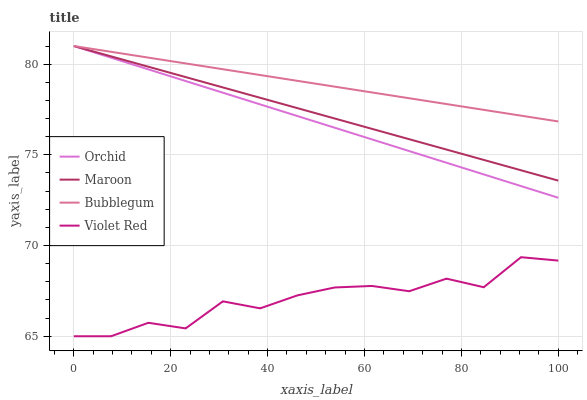Does Violet Red have the minimum area under the curve?
Answer yes or no. Yes. Does Bubblegum have the maximum area under the curve?
Answer yes or no. Yes. Does Maroon have the minimum area under the curve?
Answer yes or no. No. Does Maroon have the maximum area under the curve?
Answer yes or no. No. Is Bubblegum the smoothest?
Answer yes or no. Yes. Is Violet Red the roughest?
Answer yes or no. Yes. Is Maroon the smoothest?
Answer yes or no. No. Is Maroon the roughest?
Answer yes or no. No. Does Maroon have the lowest value?
Answer yes or no. No. Does Orchid have the highest value?
Answer yes or no. Yes. Is Violet Red less than Orchid?
Answer yes or no. Yes. Is Orchid greater than Violet Red?
Answer yes or no. Yes. Does Orchid intersect Bubblegum?
Answer yes or no. Yes. Is Orchid less than Bubblegum?
Answer yes or no. No. Is Orchid greater than Bubblegum?
Answer yes or no. No. Does Violet Red intersect Orchid?
Answer yes or no. No. 